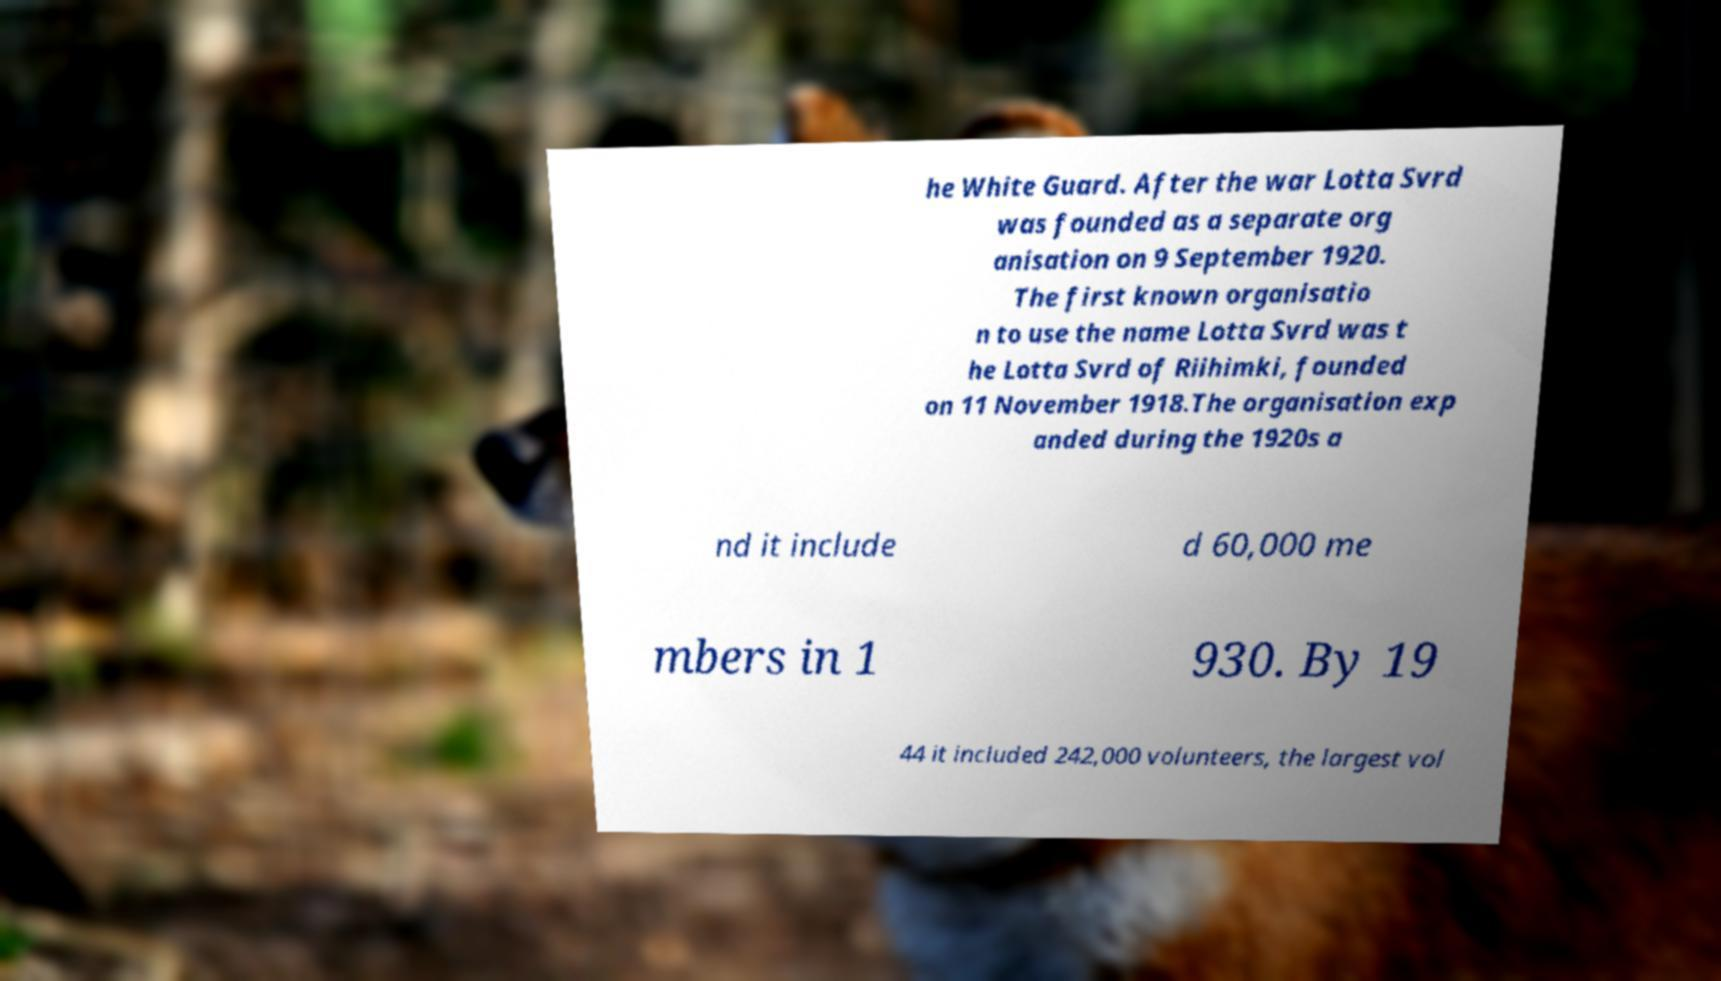Could you assist in decoding the text presented in this image and type it out clearly? he White Guard. After the war Lotta Svrd was founded as a separate org anisation on 9 September 1920. The first known organisatio n to use the name Lotta Svrd was t he Lotta Svrd of Riihimki, founded on 11 November 1918.The organisation exp anded during the 1920s a nd it include d 60,000 me mbers in 1 930. By 19 44 it included 242,000 volunteers, the largest vol 